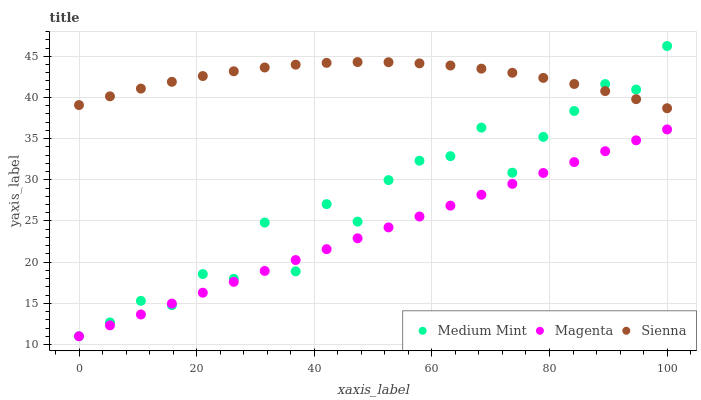Does Magenta have the minimum area under the curve?
Answer yes or no. Yes. Does Sienna have the maximum area under the curve?
Answer yes or no. Yes. Does Sienna have the minimum area under the curve?
Answer yes or no. No. Does Magenta have the maximum area under the curve?
Answer yes or no. No. Is Magenta the smoothest?
Answer yes or no. Yes. Is Medium Mint the roughest?
Answer yes or no. Yes. Is Sienna the smoothest?
Answer yes or no. No. Is Sienna the roughest?
Answer yes or no. No. Does Medium Mint have the lowest value?
Answer yes or no. Yes. Does Sienna have the lowest value?
Answer yes or no. No. Does Medium Mint have the highest value?
Answer yes or no. Yes. Does Sienna have the highest value?
Answer yes or no. No. Is Magenta less than Sienna?
Answer yes or no. Yes. Is Sienna greater than Magenta?
Answer yes or no. Yes. Does Medium Mint intersect Sienna?
Answer yes or no. Yes. Is Medium Mint less than Sienna?
Answer yes or no. No. Is Medium Mint greater than Sienna?
Answer yes or no. No. Does Magenta intersect Sienna?
Answer yes or no. No. 